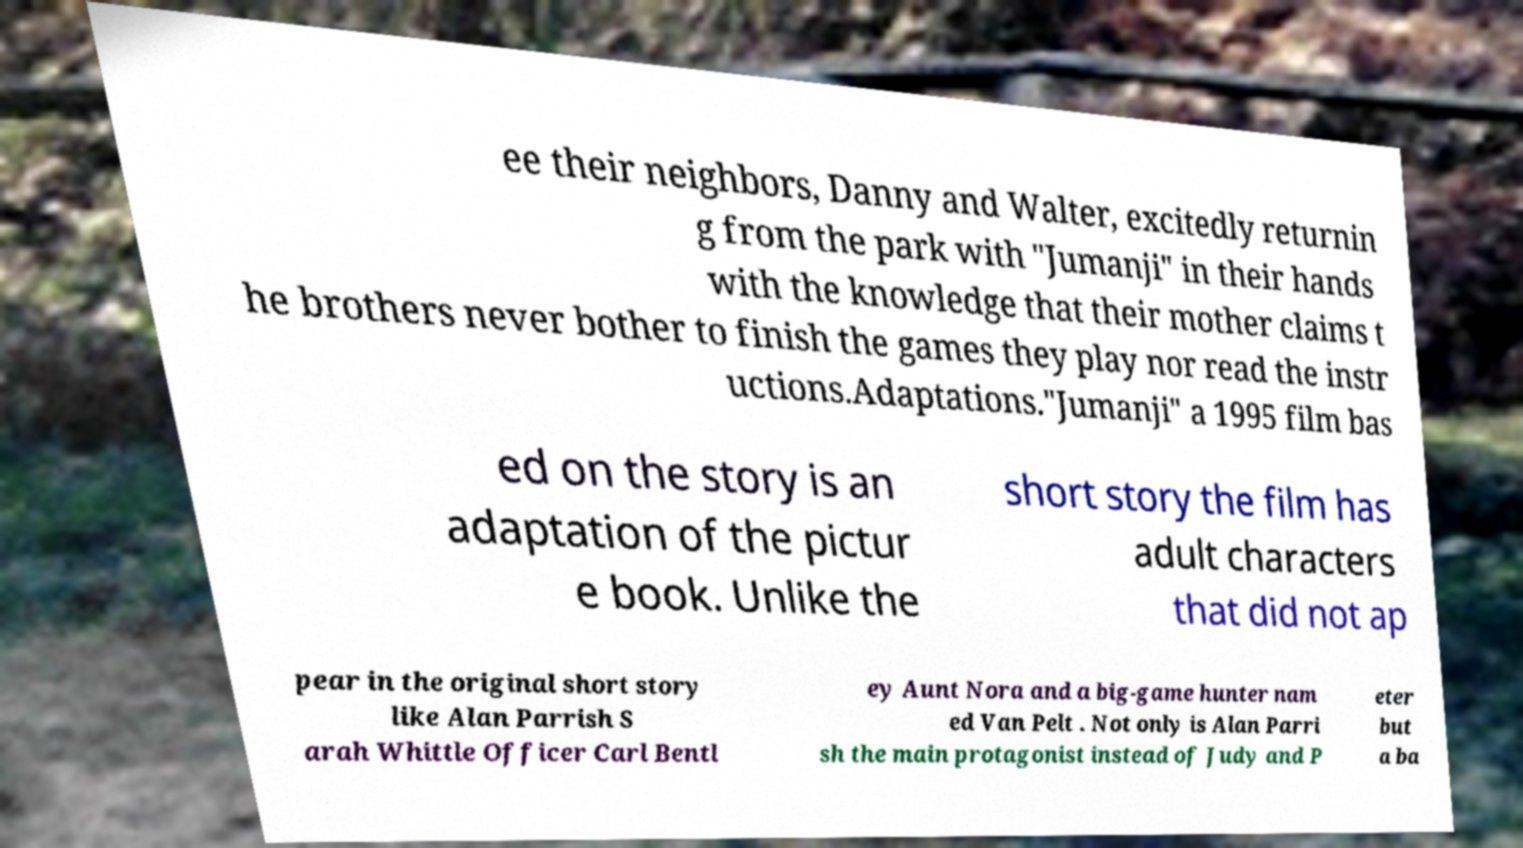For documentation purposes, I need the text within this image transcribed. Could you provide that? ee their neighbors, Danny and Walter, excitedly returnin g from the park with "Jumanji" in their hands with the knowledge that their mother claims t he brothers never bother to finish the games they play nor read the instr uctions.Adaptations."Jumanji" a 1995 film bas ed on the story is an adaptation of the pictur e book. Unlike the short story the film has adult characters that did not ap pear in the original short story like Alan Parrish S arah Whittle Officer Carl Bentl ey Aunt Nora and a big-game hunter nam ed Van Pelt . Not only is Alan Parri sh the main protagonist instead of Judy and P eter but a ba 